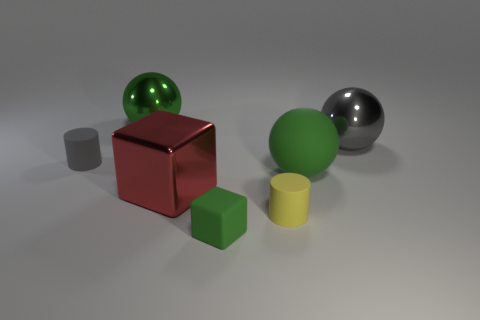There is a metallic object to the right of the tiny yellow rubber cylinder; what is its shape?
Give a very brief answer. Sphere. Are the ball that is to the left of the yellow matte object and the large gray sphere right of the yellow cylinder made of the same material?
Make the answer very short. Yes. Are there any brown things of the same shape as the big green shiny thing?
Provide a succinct answer. No. What number of things are green matte things behind the tiny yellow matte thing or blue cubes?
Offer a terse response. 1. Are there more large objects in front of the green shiny thing than tiny matte cylinders in front of the small green block?
Your response must be concise. Yes. What number of rubber objects are either large gray objects or brown things?
Your response must be concise. 0. There is a small object that is the same color as the large rubber thing; what material is it?
Offer a terse response. Rubber. Are there fewer large metal spheres to the left of the yellow thing than yellow cylinders in front of the tiny gray cylinder?
Your answer should be very brief. No. How many things are either cylinders or matte objects in front of the small gray cylinder?
Provide a short and direct response. 4. There is a gray ball that is the same size as the red thing; what material is it?
Give a very brief answer. Metal. 